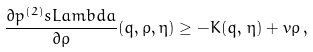<formula> <loc_0><loc_0><loc_500><loc_500>\frac { \partial p ^ { ( 2 ) } _ { \ } s L a m b d a } { \partial \rho } ( q , \rho , \eta ) \geq - K ( q , \, \eta ) + v \rho \, ,</formula> 